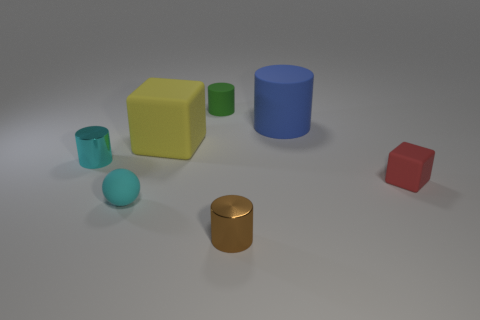How many yellow things are behind the small metallic object that is behind the red rubber cube? 1 